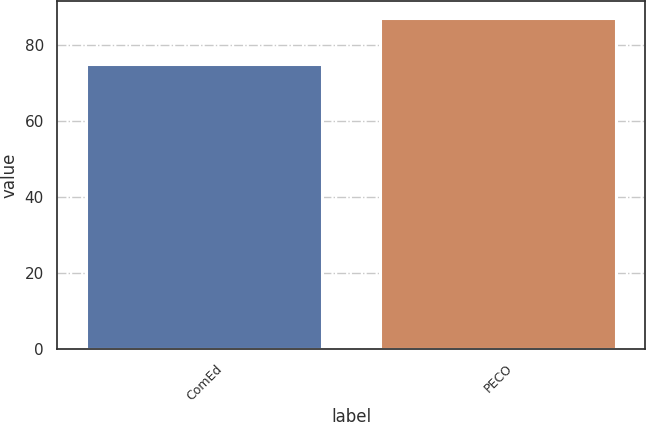<chart> <loc_0><loc_0><loc_500><loc_500><bar_chart><fcel>ComEd<fcel>PECO<nl><fcel>75<fcel>87<nl></chart> 